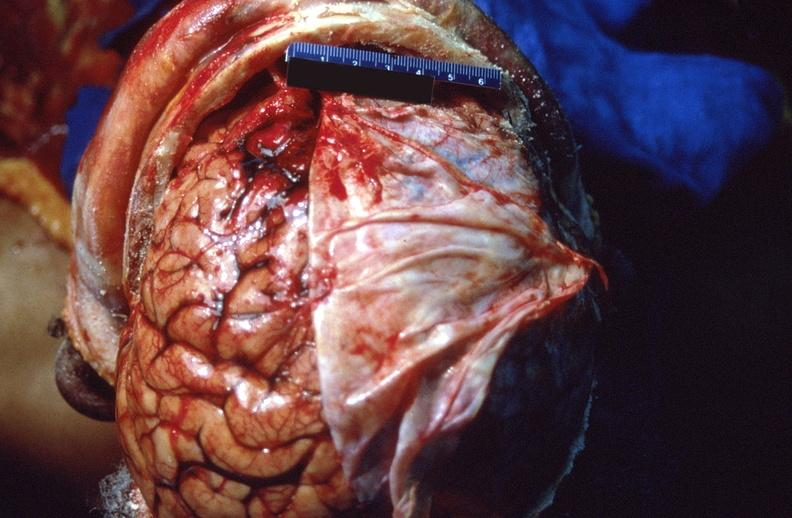what does this image show?
Answer the question using a single word or phrase. Brain 